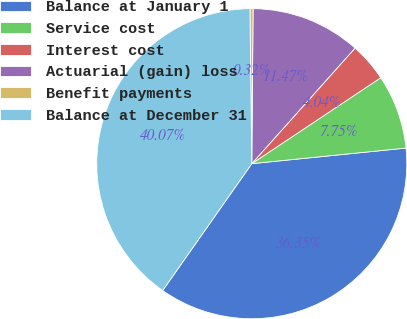Convert chart to OTSL. <chart><loc_0><loc_0><loc_500><loc_500><pie_chart><fcel>Balance at January 1<fcel>Service cost<fcel>Interest cost<fcel>Actuarial (gain) loss<fcel>Benefit payments<fcel>Balance at December 31<nl><fcel>36.35%<fcel>7.75%<fcel>4.04%<fcel>11.47%<fcel>0.32%<fcel>40.07%<nl></chart> 